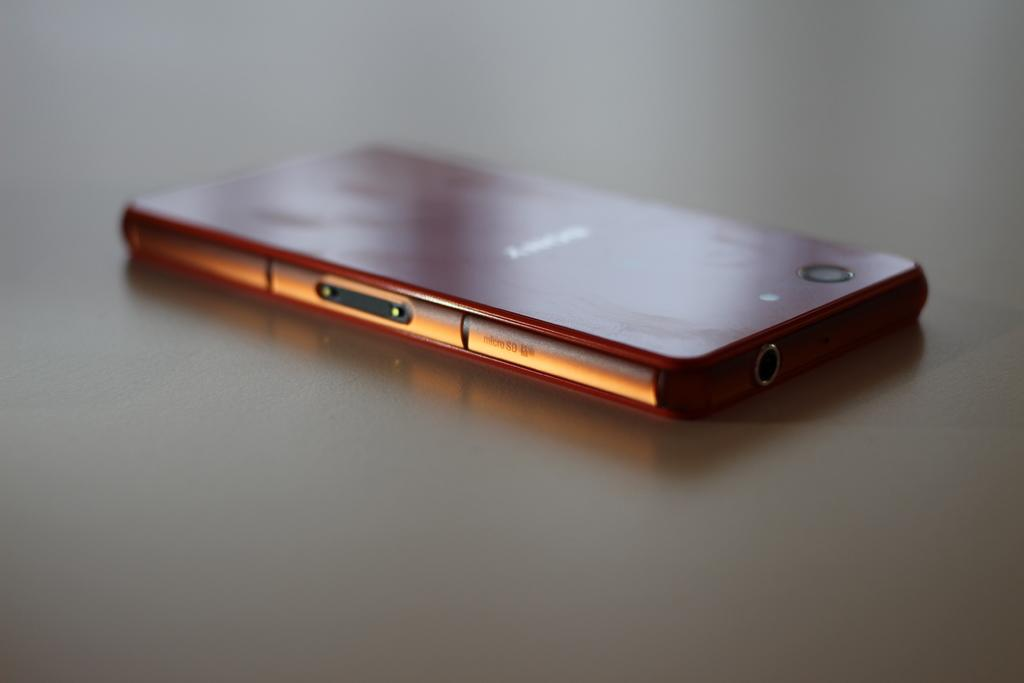What can be seen hanging in the image? There is a mobile in the image. Can you describe the mobile in more detail? Unfortunately, the provided facts do not offer any additional details about the mobile. What type of underwear is hanging from the mobile in the image? There is no underwear present in the image; only a mobile can be seen. 